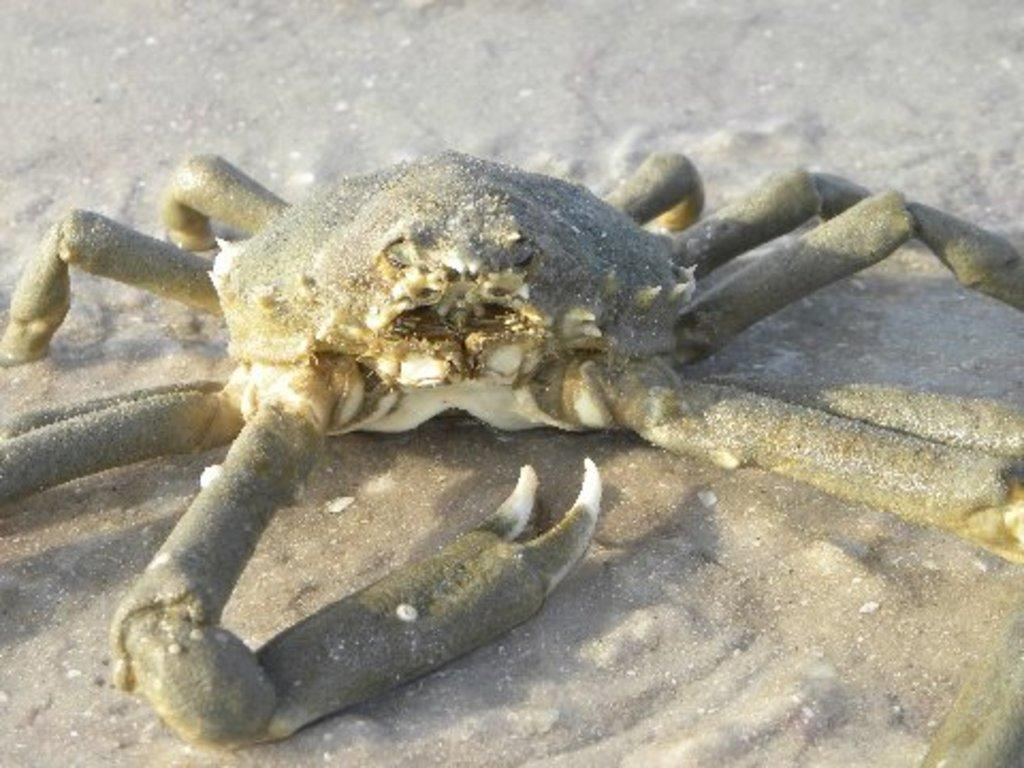What is placed on the ground in the image? There is a grab on the ground. What type of learning can be observed taking place in the image? There is no learning activity present in the image; it features a grab on the ground. What type of sail is visible in the image? There is no sail present in the image; it features a grab on the ground. 